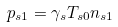<formula> <loc_0><loc_0><loc_500><loc_500>p _ { s 1 } = \gamma _ { s } T _ { s 0 } n _ { s 1 }</formula> 